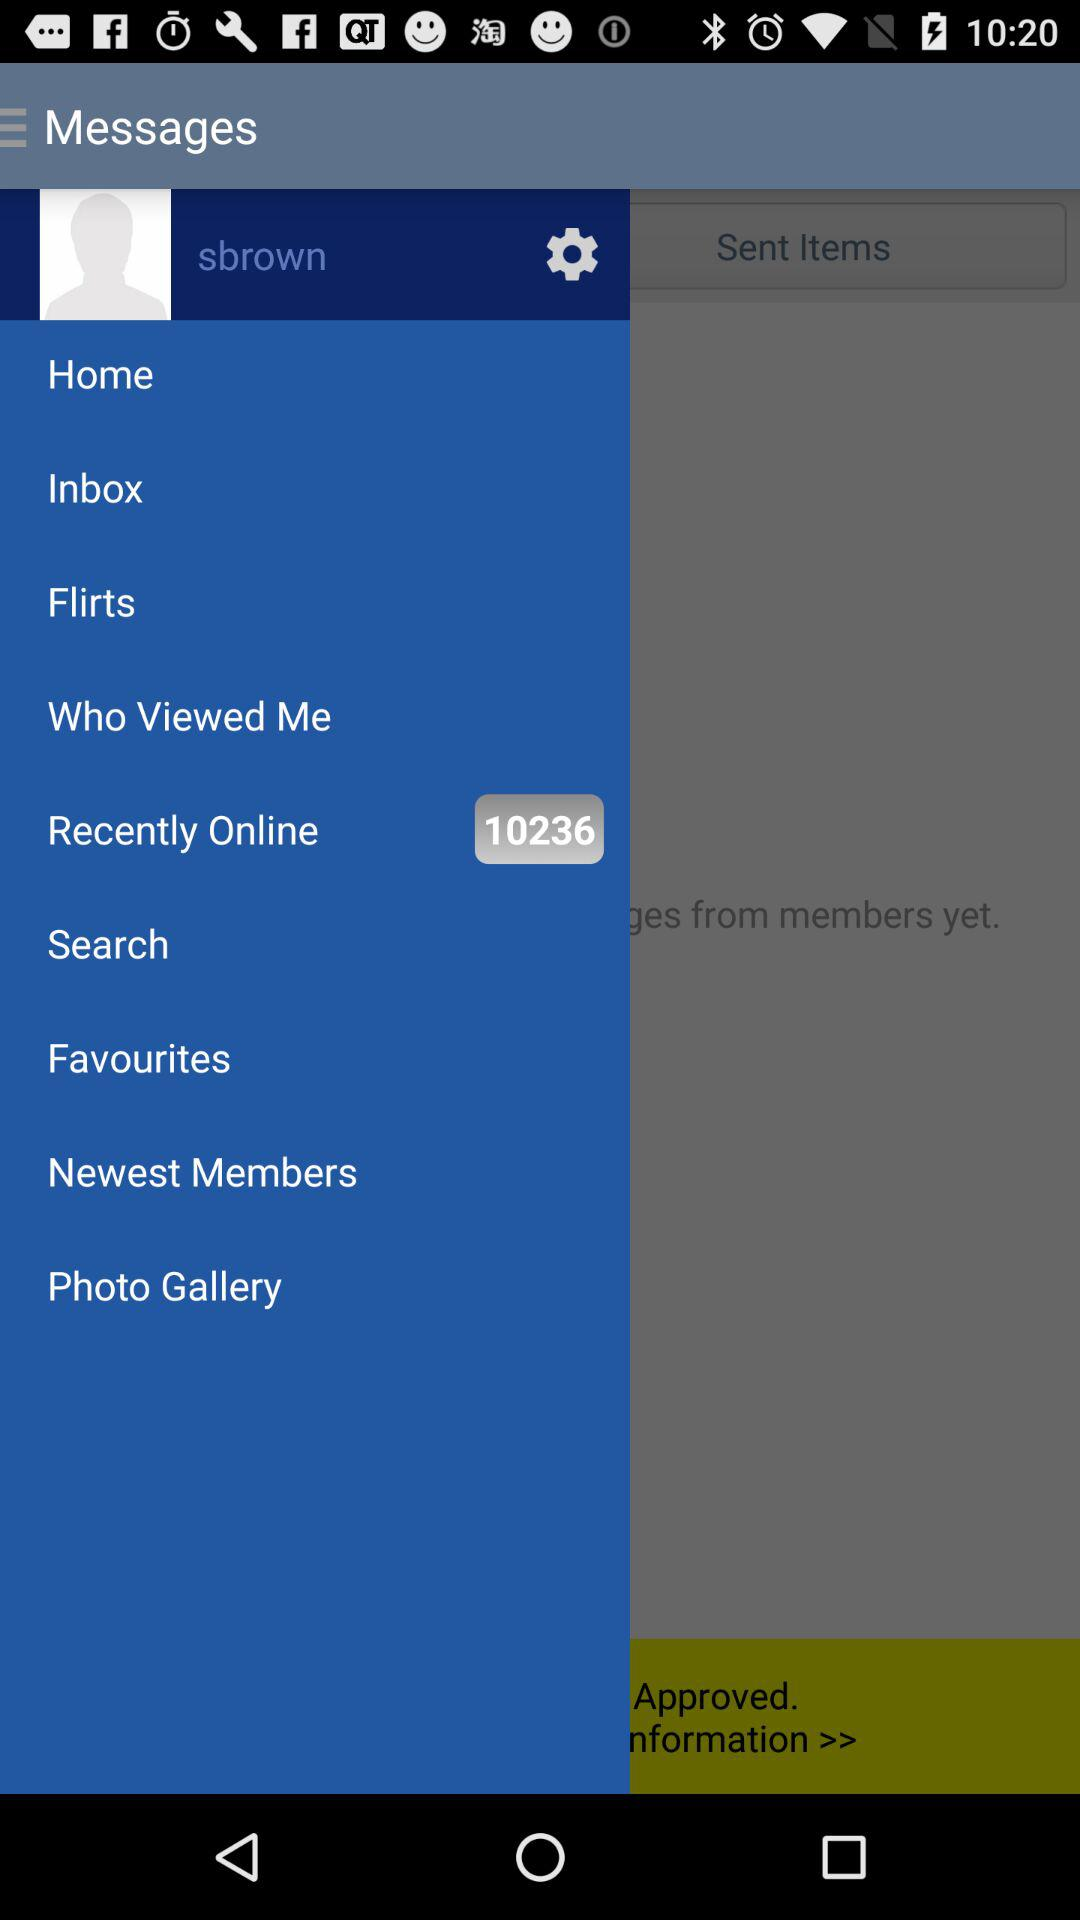What is the user name? The user name is "sbrown". 